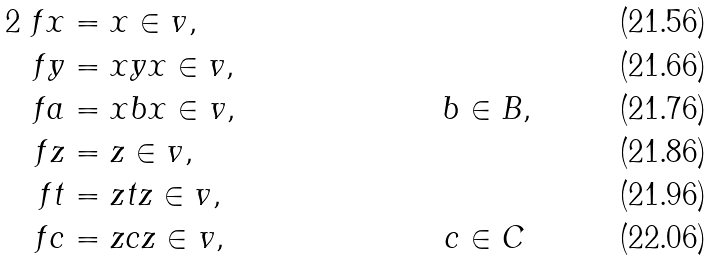<formula> <loc_0><loc_0><loc_500><loc_500>2 \ f x & = x \in v , \\ \ f y & = x y x \in v , \\ \ f a & = x b x \in v , \quad & b & \in B , \\ \ f z & = z \in v , \\ \ f t & = z t z \in v , \\ \ f c & = z c z \in v , \quad & c & \in C</formula> 